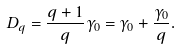Convert formula to latex. <formula><loc_0><loc_0><loc_500><loc_500>D _ { q } = \frac { q + 1 } { q } \gamma _ { 0 } = \gamma _ { 0 } + \frac { \gamma _ { 0 } } { q } .</formula> 